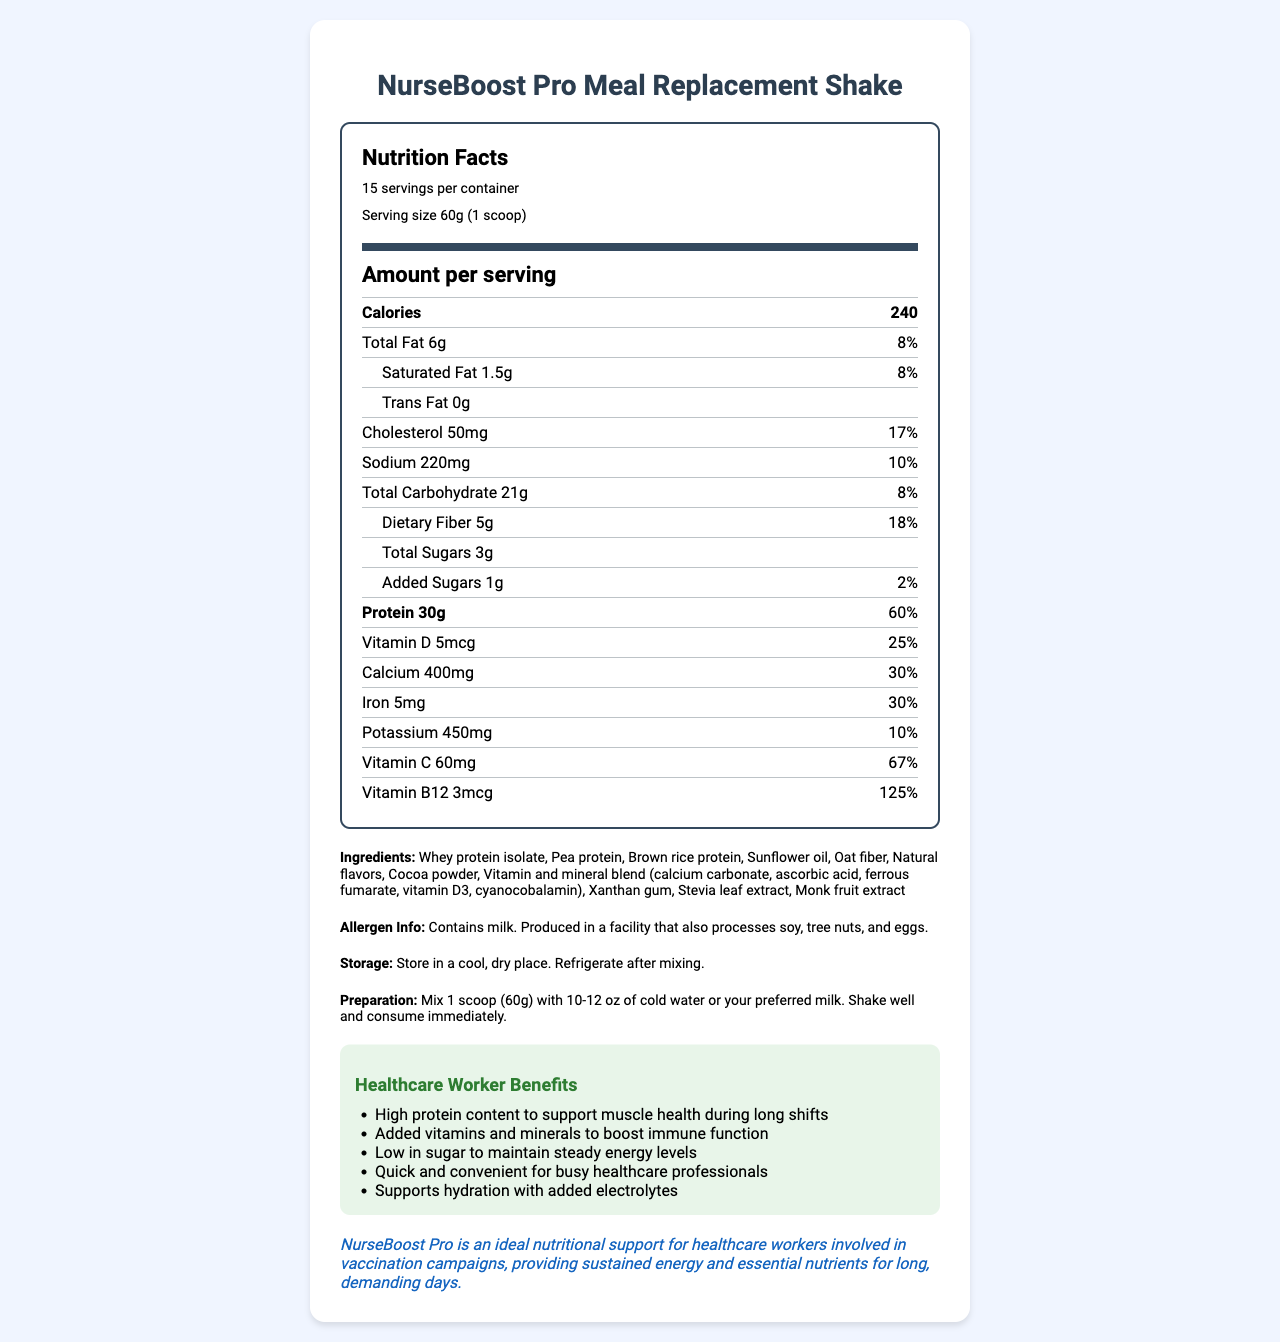what is the serving size? The document specifies the serving size as "60g (1 scoop)".
Answer: 60g (1 scoop) how many servings are there per container? The document mentions that there are "15 servings per container".
Answer: 15 how many calories are in one serving? The document lists the calories per serving as "240".
Answer: 240 how much total fat is in one serving, and what percentage of daily value does it represent? The document specifies that one serving contains 6g of total fat, which is 8% of the daily value.
Answer: 6g, 8% what is the purpose of the healthcare worker benefits section? The document includes a section titled "Healthcare Worker Benefits", listing advantages such as high protein content and added vitamins to support immune function.
Answer: To highlight the benefits of the product for healthcare workers during long shifts which ingredient is not listed in the Nutrition Facts Label? A. Xanthan gum B. Soy protein C. Stevia leaf extract D. Vitamin D3 The ingredients listed in the document are "Whey protein isolate, Pea protein, Brown rice protein, Sunflower oil, Oat fiber, Natural flavors, Cocoa powder, Vitamin and mineral blend (calcium carbonate, ascorbic acid, ferrous fumarate, vitamin D3, cyanocobalamin), Xanthan gum, Stevia leaf extract, Monk fruit extract". Soy protein is not included.
Answer: B. Soy protein what is the daily value percentage of vitamin B12 per serving? A. 67% B. 125% C. 30% D. 25% The document lists the daily value percentage for vitamin B12 as 125%.
Answer: B. 125% does this product contain any milk? The allergen information states "Contains milk".
Answer: Yes what are the preparation instructions for this product? The preparation instructions provided in the document are "Mix 1 scoop (60g) with 10-12 oz of cold water or your preferred milk. Shake well and consume immediately."
Answer: Mix 1 scoop (60g) with 10-12 oz of cold water or your preferred milk. Shake well and consume immediately. summarize the main purpose of the document. The document focuses on the nutrition facts of NurseBoost Pro Meal Replacement Shake, its benefits for healthcare workers, and how to prepare and store the product.
Answer: The document provides detailed nutritional information about NurseBoost Pro Meal Replacement Shake, highlighting its health benefits for healthcare workers, including high protein content, added vitamins and minerals, and convenience. It also includes preparation and storage instructions. what is the daily value percentage for potassium in one serving? The document lists the daily value percentage for potassium as 10%.
Answer: 10% what are the added sugars in one serving? The document specifies that one serving contains 1g of added sugars, which is 2% of the daily value.
Answer: 1g, 2% are there any storage instructions provided? The document includes storage instructions: "Store in a cool, dry place. Refrigerate after mixing."
Answer: Yes why is the product suitable for healthcare workers involved in vaccination campaigns? The vaccination campaign note mentions that NurseBoost Pro is ideal nutritional support for healthcare workers involved in vaccination campaigns providing sustained energy and essential nutrients.
Answer: The product provides sustained energy and essential nutrients for long, demanding days which are common in vaccination campaigns. how much calcium is present in a single serving? The document states that there are 400mg of calcium in a single serving.
Answer: 400mg what's the total carbohydrate content, and what is the dietary fiber content in one serving? The document specifies that one serving contains 21g of total carbohydrates and 5g of dietary fiber.
Answer: Total Carbohydrate: 21g, Dietary Fiber: 5g what flavoring ingredients are used in this product? The ingredients section mentions these flavoring components.
Answer: Natural flavors, Cocoa powder, Stevia leaf extract, Monk fruit extract 